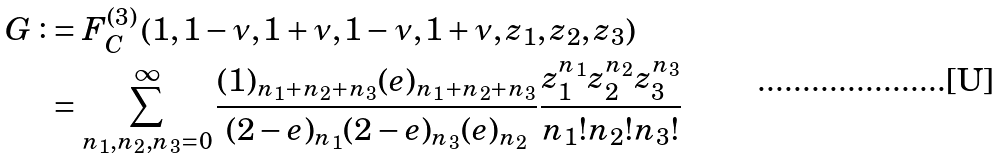Convert formula to latex. <formula><loc_0><loc_0><loc_500><loc_500>G \vcentcolon & = F _ { C } ^ { ( 3 ) } \left ( 1 , 1 - \nu , 1 + \nu , 1 - \nu , 1 + \nu , z _ { 1 } , z _ { 2 } , z _ { 3 } \right ) \\ & = \sum _ { n _ { 1 } , n _ { 2 } , n _ { 3 } = 0 } ^ { \infty } \frac { ( 1 ) _ { n _ { 1 } + n _ { 2 } + n _ { 3 } } ( e ) _ { n _ { 1 } + n _ { 2 } + n _ { 3 } } } { ( 2 - e ) _ { n _ { 1 } } ( 2 - e ) _ { n _ { 3 } } ( e ) _ { n _ { 2 } } } \frac { z _ { 1 } ^ { n _ { 1 } } z _ { 2 } ^ { n _ { 2 } } z _ { 3 } ^ { n _ { 3 } } } { n _ { 1 } ! n _ { 2 } ! n _ { 3 } ! }</formula> 